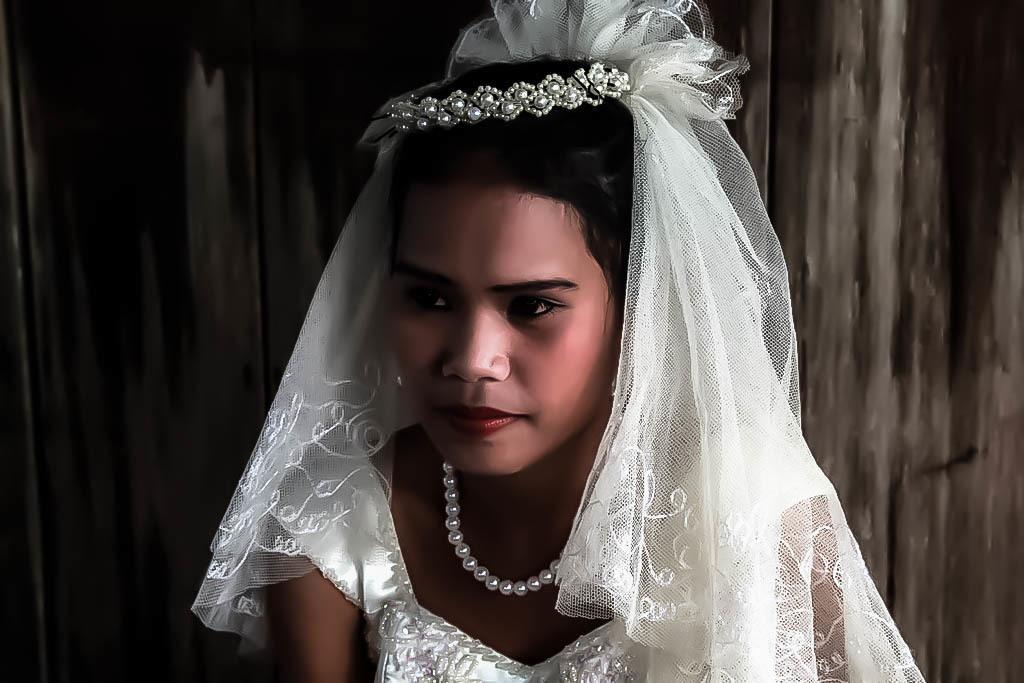Could you give a brief overview of what you see in this image? In this image we can see a person wearing a white color dress and there is a pearl set on her neck. 